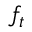<formula> <loc_0><loc_0><loc_500><loc_500>f _ { t }</formula> 